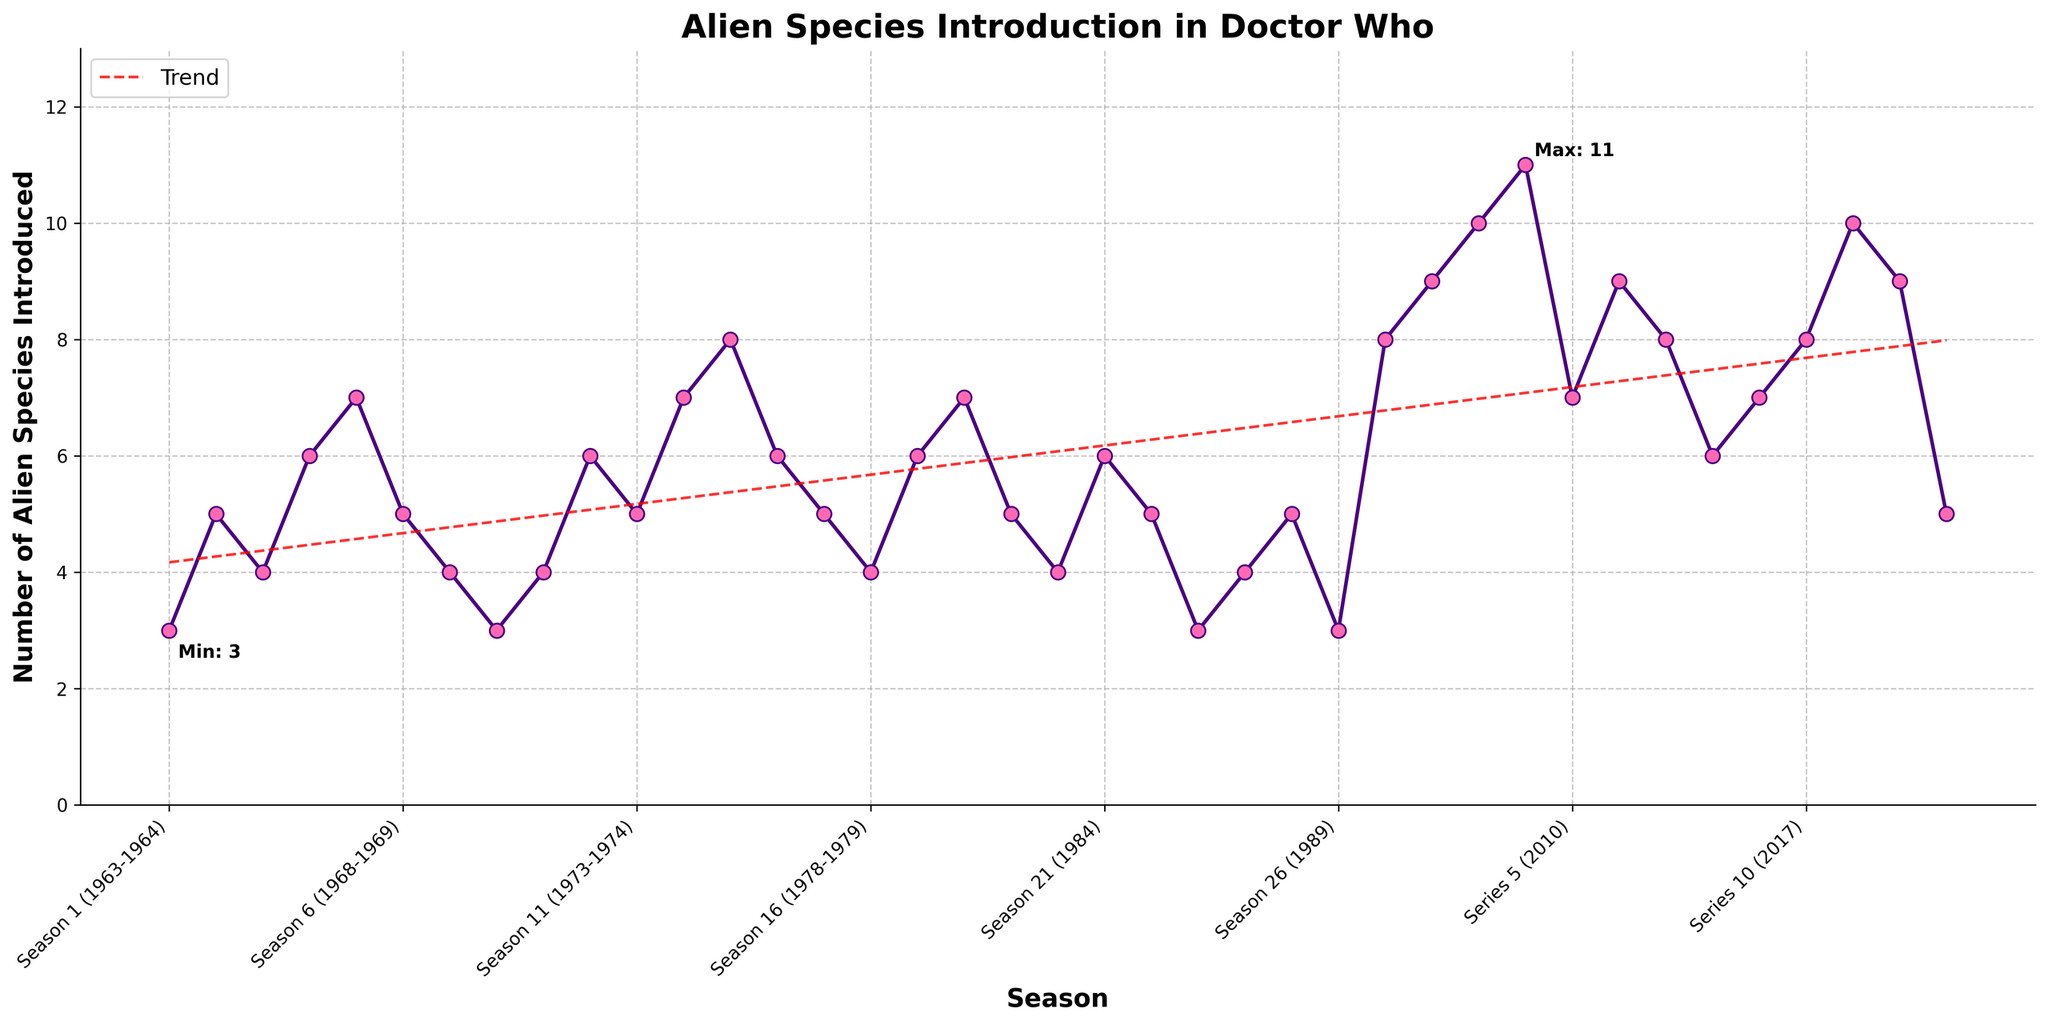When was the maximum number of alien species introduced? The figure annotates the maximum point where the number of alien species introduced was highest. From the annotation and the X-axis labels, the season corresponding to the maximum point is Series 4 (2008).
Answer: Series 4 (2008) What’s the average number of alien species introduced in the first 5 seasons? Sum the alien species introduced in the first 5 seasons (3 + 5 + 4 + 6 + 7) which equals 25, then divide by 5. So the average is 25 / 5 = 5.
Answer: 5 How did the number of alien species introduced change from Season 4 to Season 5? From the figure, Season 4 (6 alien species) and Season 5 (7 alien species) show that the number of alien species introduced increased by 1.
Answer: Increased by 1 Which seasons had the minimum number of alien species introduced? The figure annotates the minimum point and shows that Seasons 8 and 26 each had the least number of alien species, which is 3.
Answer: Seasons 8, 26 Identify the periods with the highest and lowest trend in alien species introduction. The trend line shows a general upward slope until Series 4 (2008), followed by fluctuations. The highest trend period is from Series 1 (2005) to Series 4 (2008). The lowest trend appears between Seasons 22 (1985) and Seasons 8 (1971).
Answer: Highest: Series 1-4, Lowest: Seasons 22-8 What’s the difference between the number of alien species introduced in Season 10 and Series 10? From the figure, Season 10 introduced 6, and Series 10 introduced 8 alien species. The difference is 8 - 6 = 2.
Answer: 2 Compare the alien species introduction between the Classic era (Seasons 1-26) and the Modern era (Series 1-13). Calculate the sum of alien species for each era. Classic era: (3 + 5 + ... + 3) = 118, Modern era: (8 + 9 + ... + 5) = 97. The Classic era introduced more alien species.
Answer: Classic > Modern In which year did the number of alien species introduced peak since the revival in 2005? According to the figure, Series 4 (2008) had the peak number of alien species introduced since 2005.
Answer: Series 4 (2008) What was the trend of alien species introduction from Series 2 to Series 4? From the figure, Series 2 had 9, Series 3 had 10, and Series 4 had 11 alien species, indicating an increasing trend.
Answer: Increasing What is the most frequent number of alien species introduced per season? Counting each occurrence, the most frequent numbers introduced were 5 (seven times).
Answer: 5 